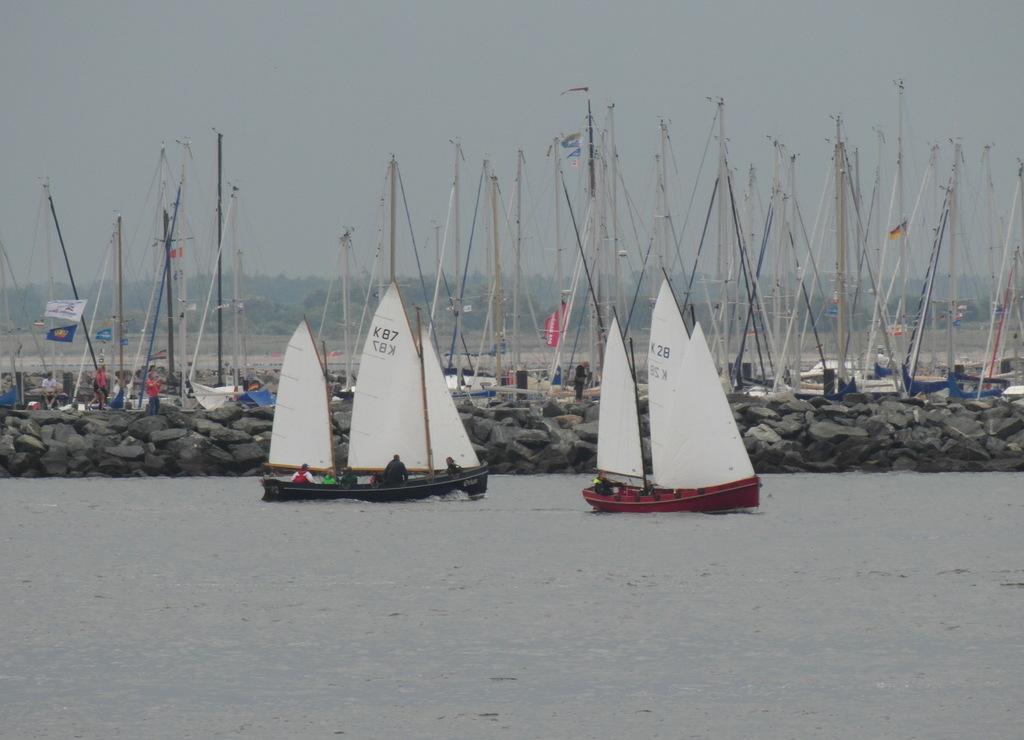Describe this image in one or two sentences. In the image we can see there are sail boats in the water and there are many boats standing on the water. 